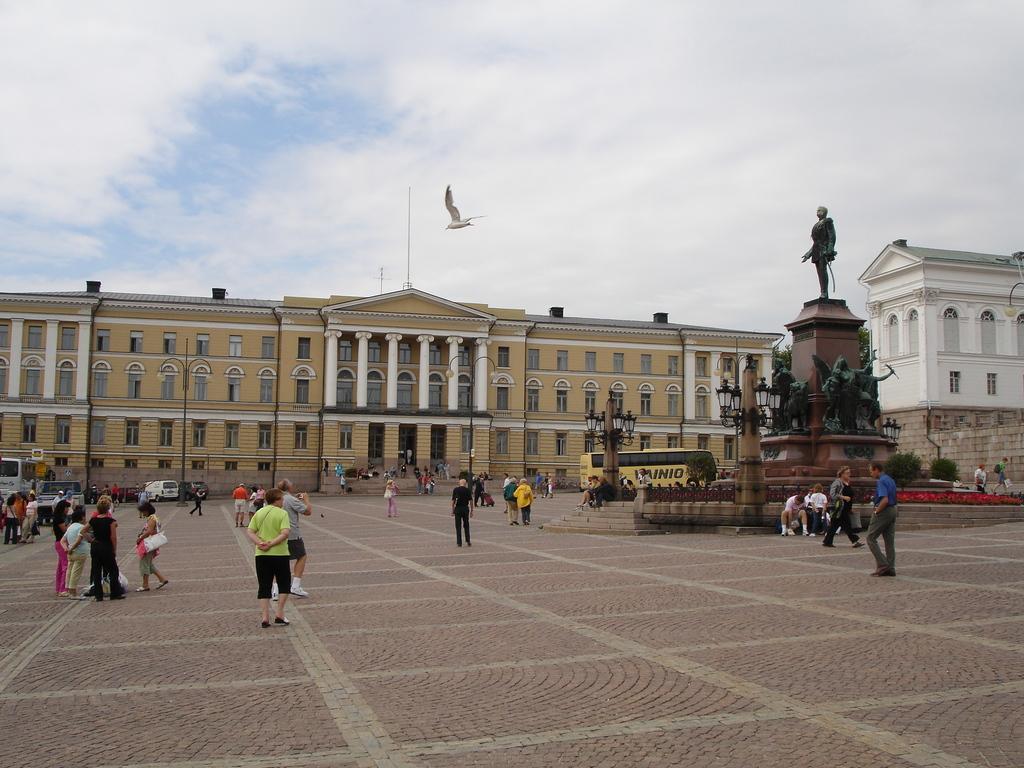In one or two sentences, can you explain what this image depicts? In this image I can see group of people, some are standing and some are walking and I can also see few statues, light poles, buildings and I can also see the bird in the air and the sky is in blue and white color. 